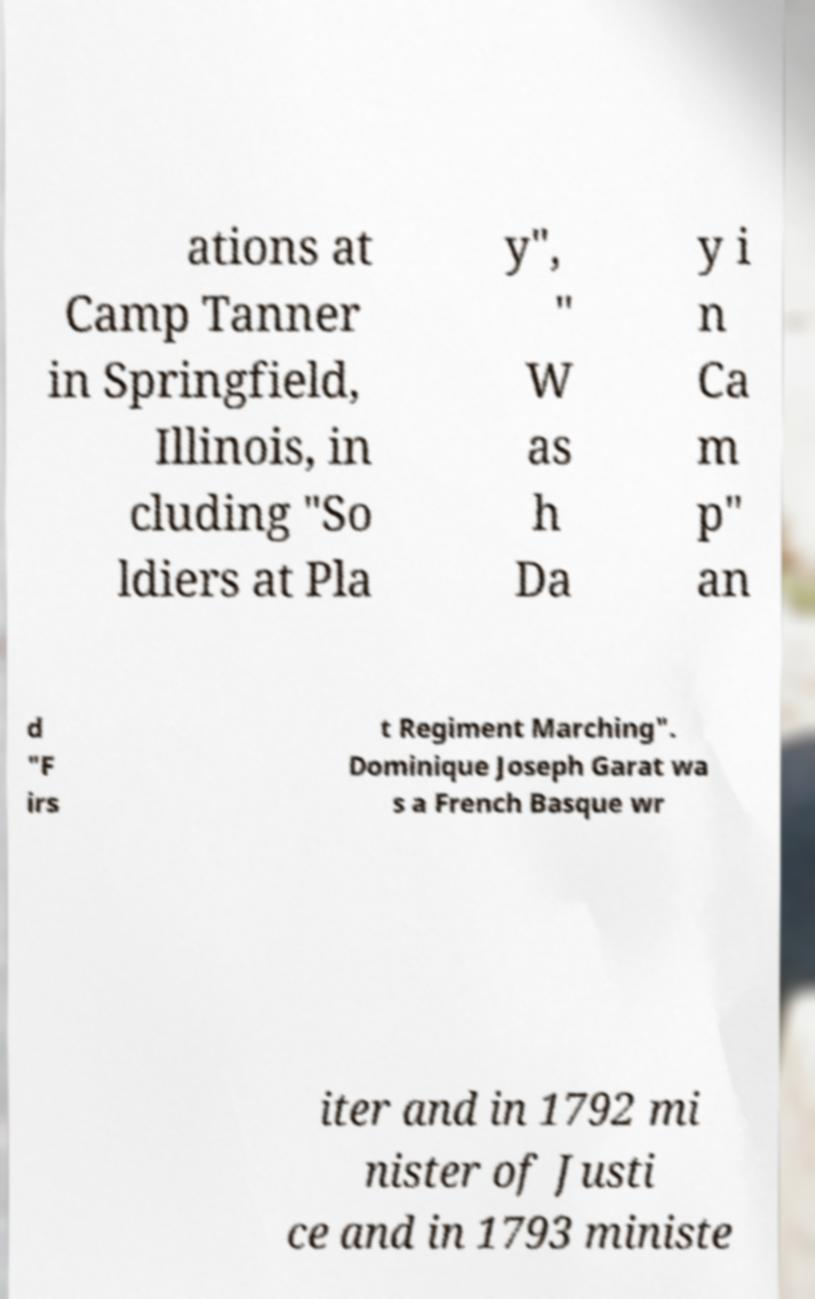Could you extract and type out the text from this image? ations at Camp Tanner in Springfield, Illinois, in cluding "So ldiers at Pla y", " W as h Da y i n Ca m p" an d "F irs t Regiment Marching". Dominique Joseph Garat wa s a French Basque wr iter and in 1792 mi nister of Justi ce and in 1793 ministe 